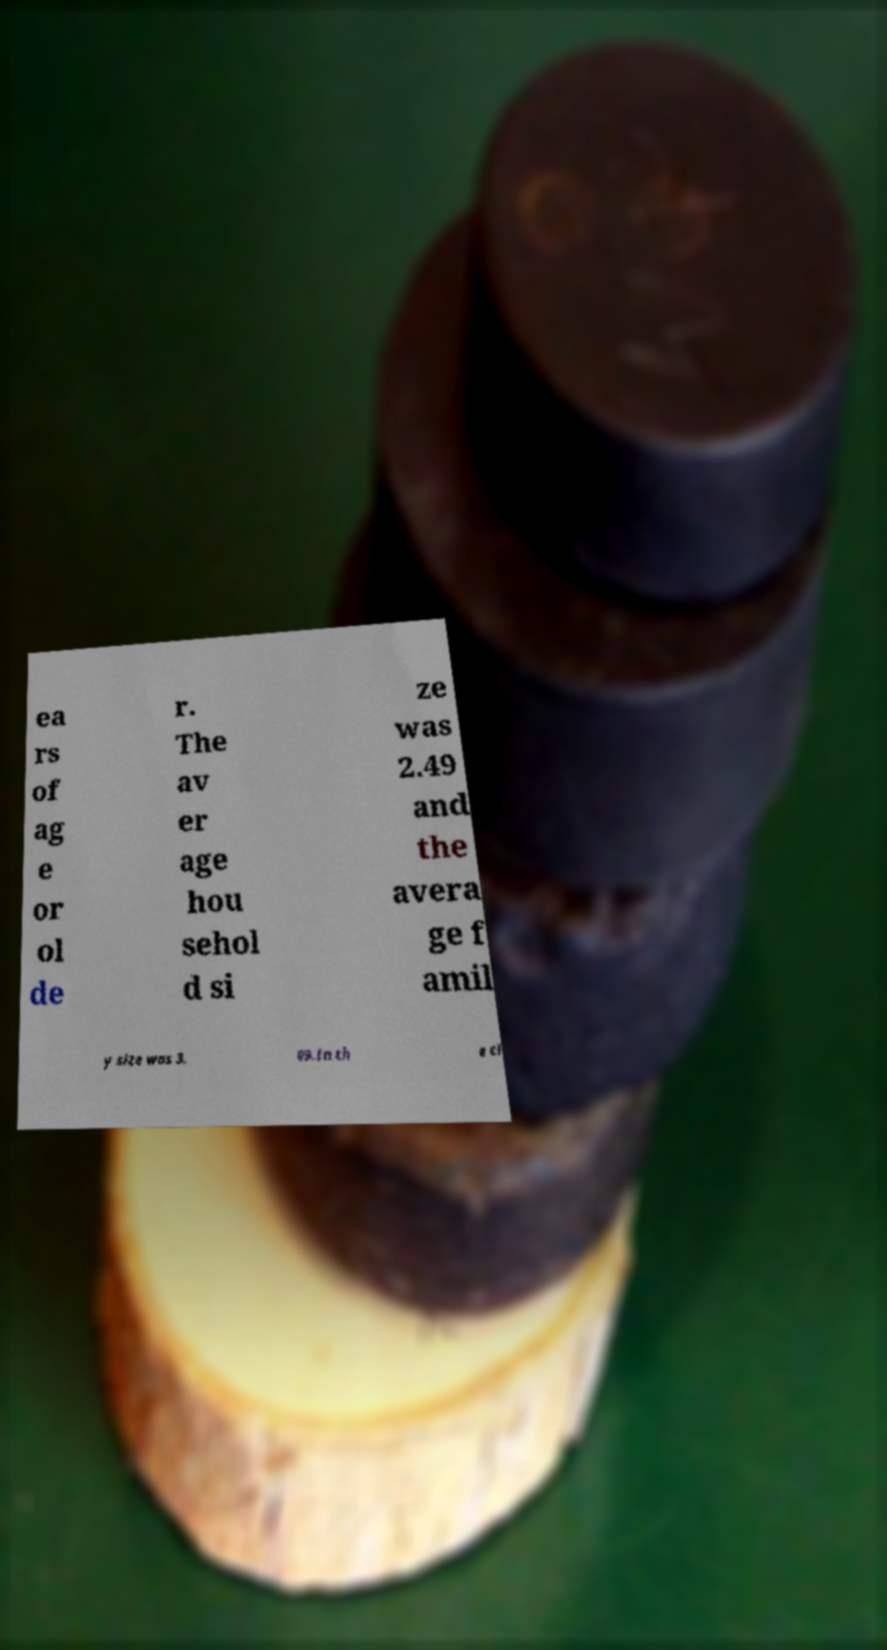There's text embedded in this image that I need extracted. Can you transcribe it verbatim? ea rs of ag e or ol de r. The av er age hou sehol d si ze was 2.49 and the avera ge f amil y size was 3. 09.In th e ci 